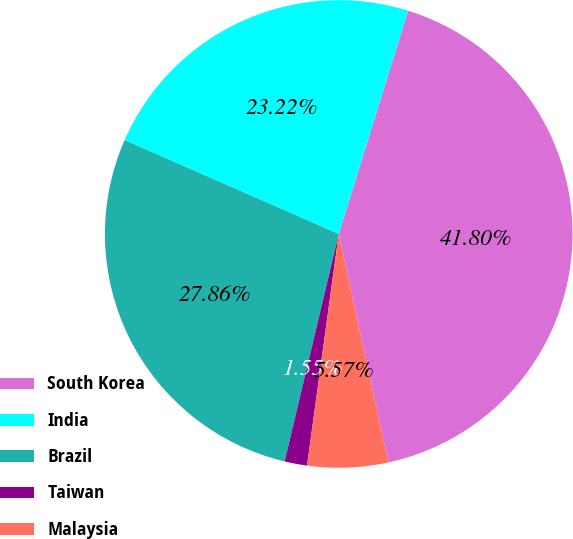Convert chart to OTSL. <chart><loc_0><loc_0><loc_500><loc_500><pie_chart><fcel>South Korea<fcel>India<fcel>Brazil<fcel>Taiwan<fcel>Malaysia<nl><fcel>41.8%<fcel>23.22%<fcel>27.86%<fcel>1.55%<fcel>5.57%<nl></chart> 